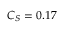Convert formula to latex. <formula><loc_0><loc_0><loc_500><loc_500>C _ { S } = 0 . 1 7</formula> 